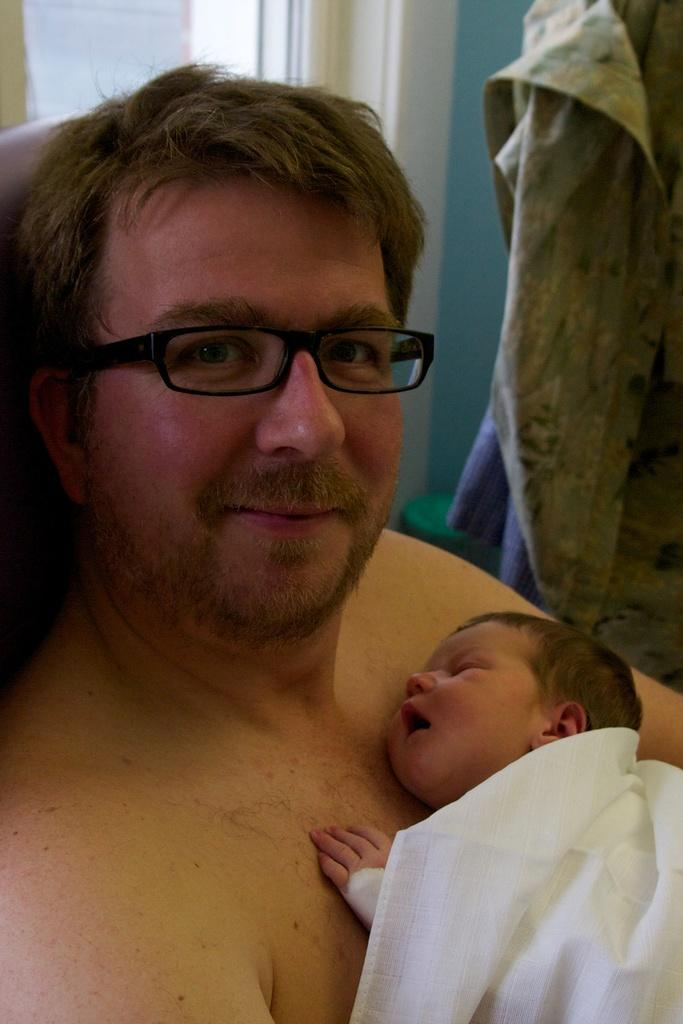Who is the main subject in the foreground of the image? There is a man in the foreground of the image. What is the man doing in the image? The man appears to be holding a baby. What can be seen in the background of the image? There is a wall, clothes, and other objects visible in the background. What type of winter clothing is the dog wearing in the image? There is no dog present in the image, and therefore no winter clothing for a dog can be observed. 